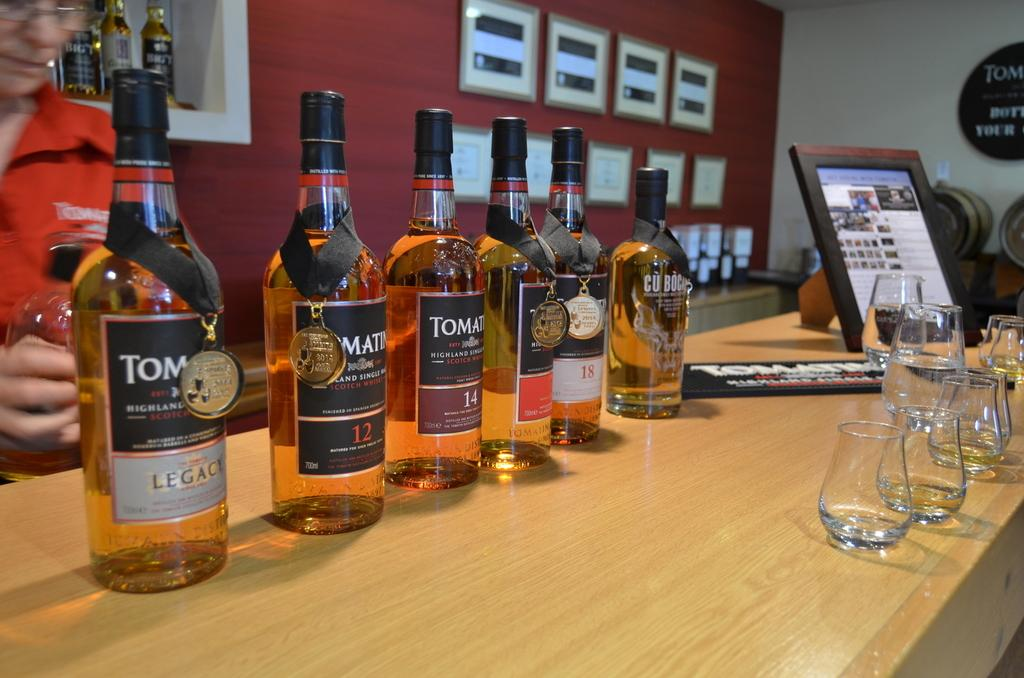<image>
Create a compact narrative representing the image presented. Several bottles of alcohol on a bar, one of which has the number 12 on it. 